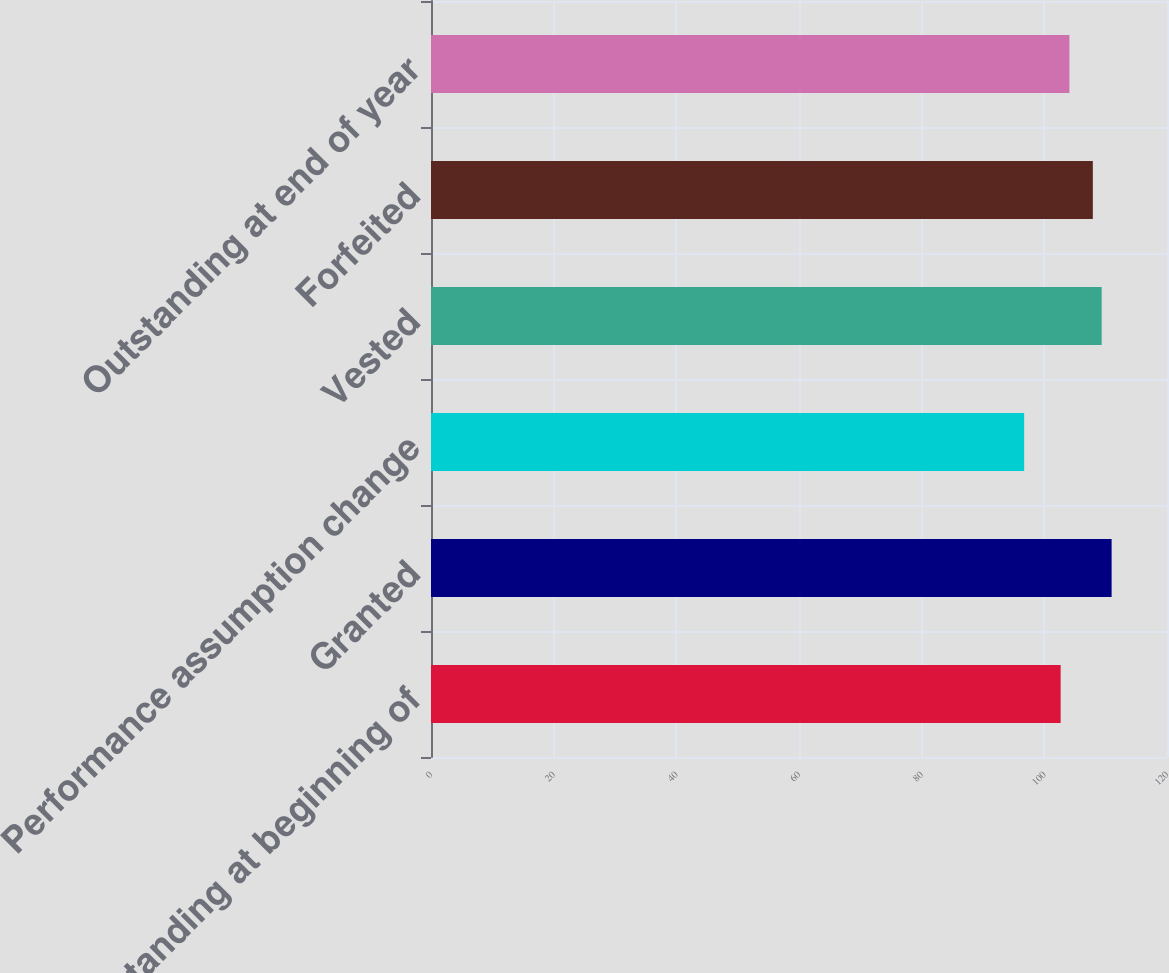Convert chart to OTSL. <chart><loc_0><loc_0><loc_500><loc_500><bar_chart><fcel>Outstanding at beginning of<fcel>Granted<fcel>Performance assumption change<fcel>Vested<fcel>Forfeited<fcel>Outstanding at end of year<nl><fcel>102.66<fcel>110.97<fcel>96.71<fcel>109.35<fcel>107.91<fcel>104.09<nl></chart> 